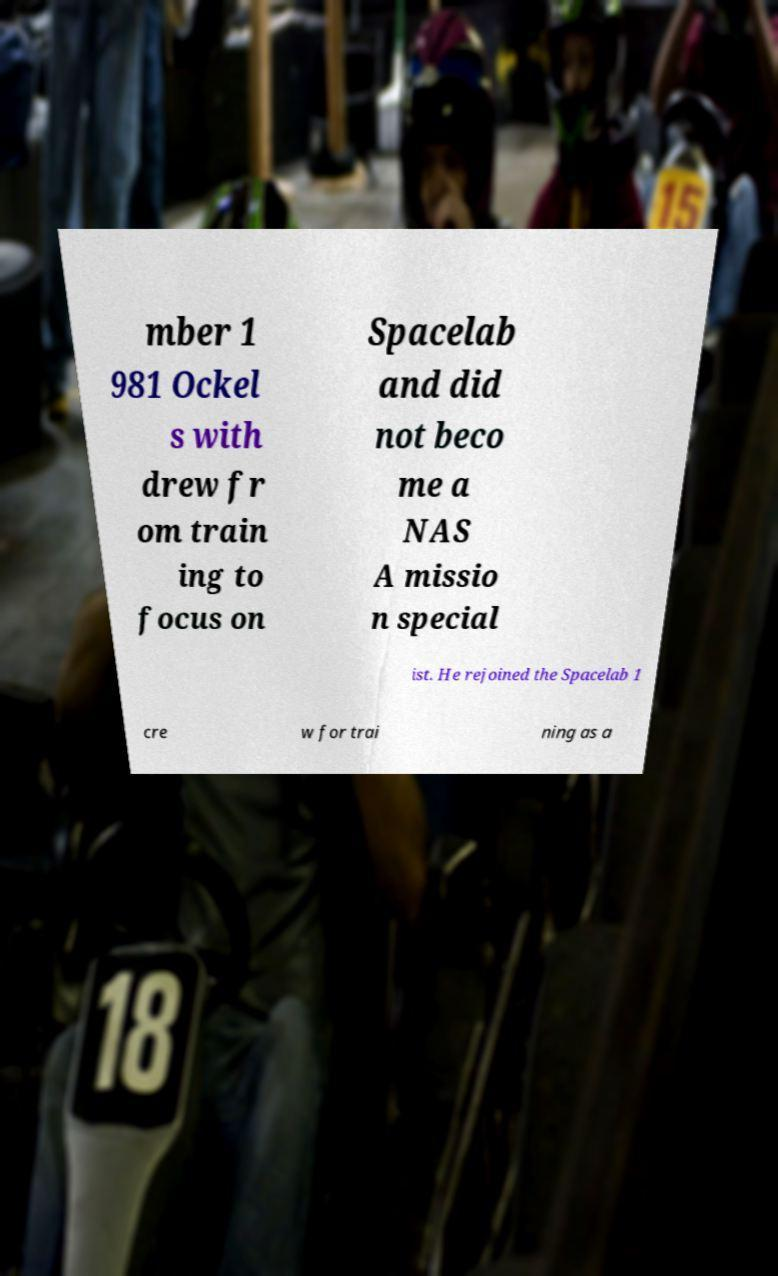For documentation purposes, I need the text within this image transcribed. Could you provide that? mber 1 981 Ockel s with drew fr om train ing to focus on Spacelab and did not beco me a NAS A missio n special ist. He rejoined the Spacelab 1 cre w for trai ning as a 